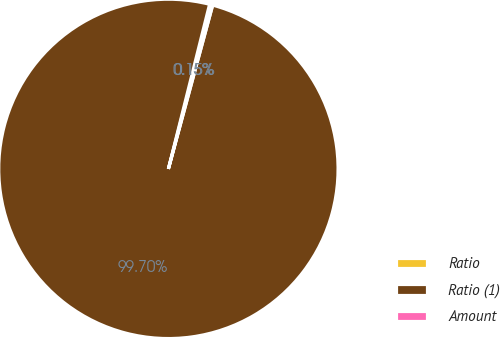Convert chart to OTSL. <chart><loc_0><loc_0><loc_500><loc_500><pie_chart><fcel>Ratio<fcel>Ratio (1)<fcel>Amount<nl><fcel>0.15%<fcel>99.7%<fcel>0.15%<nl></chart> 